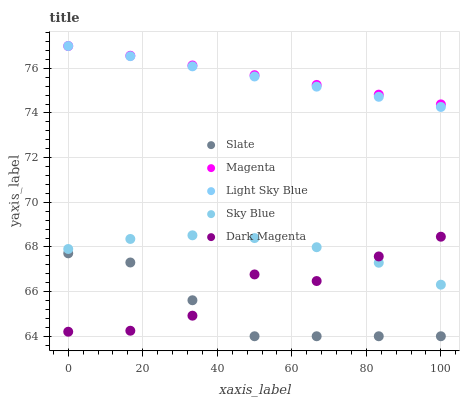Does Slate have the minimum area under the curve?
Answer yes or no. Yes. Does Magenta have the maximum area under the curve?
Answer yes or no. Yes. Does Light Sky Blue have the minimum area under the curve?
Answer yes or no. No. Does Light Sky Blue have the maximum area under the curve?
Answer yes or no. No. Is Light Sky Blue the smoothest?
Answer yes or no. Yes. Is Dark Magenta the roughest?
Answer yes or no. Yes. Is Slate the smoothest?
Answer yes or no. No. Is Slate the roughest?
Answer yes or no. No. Does Slate have the lowest value?
Answer yes or no. Yes. Does Light Sky Blue have the lowest value?
Answer yes or no. No. Does Magenta have the highest value?
Answer yes or no. Yes. Does Slate have the highest value?
Answer yes or no. No. Is Slate less than Sky Blue?
Answer yes or no. Yes. Is Magenta greater than Dark Magenta?
Answer yes or no. Yes. Does Magenta intersect Light Sky Blue?
Answer yes or no. Yes. Is Magenta less than Light Sky Blue?
Answer yes or no. No. Is Magenta greater than Light Sky Blue?
Answer yes or no. No. Does Slate intersect Sky Blue?
Answer yes or no. No. 